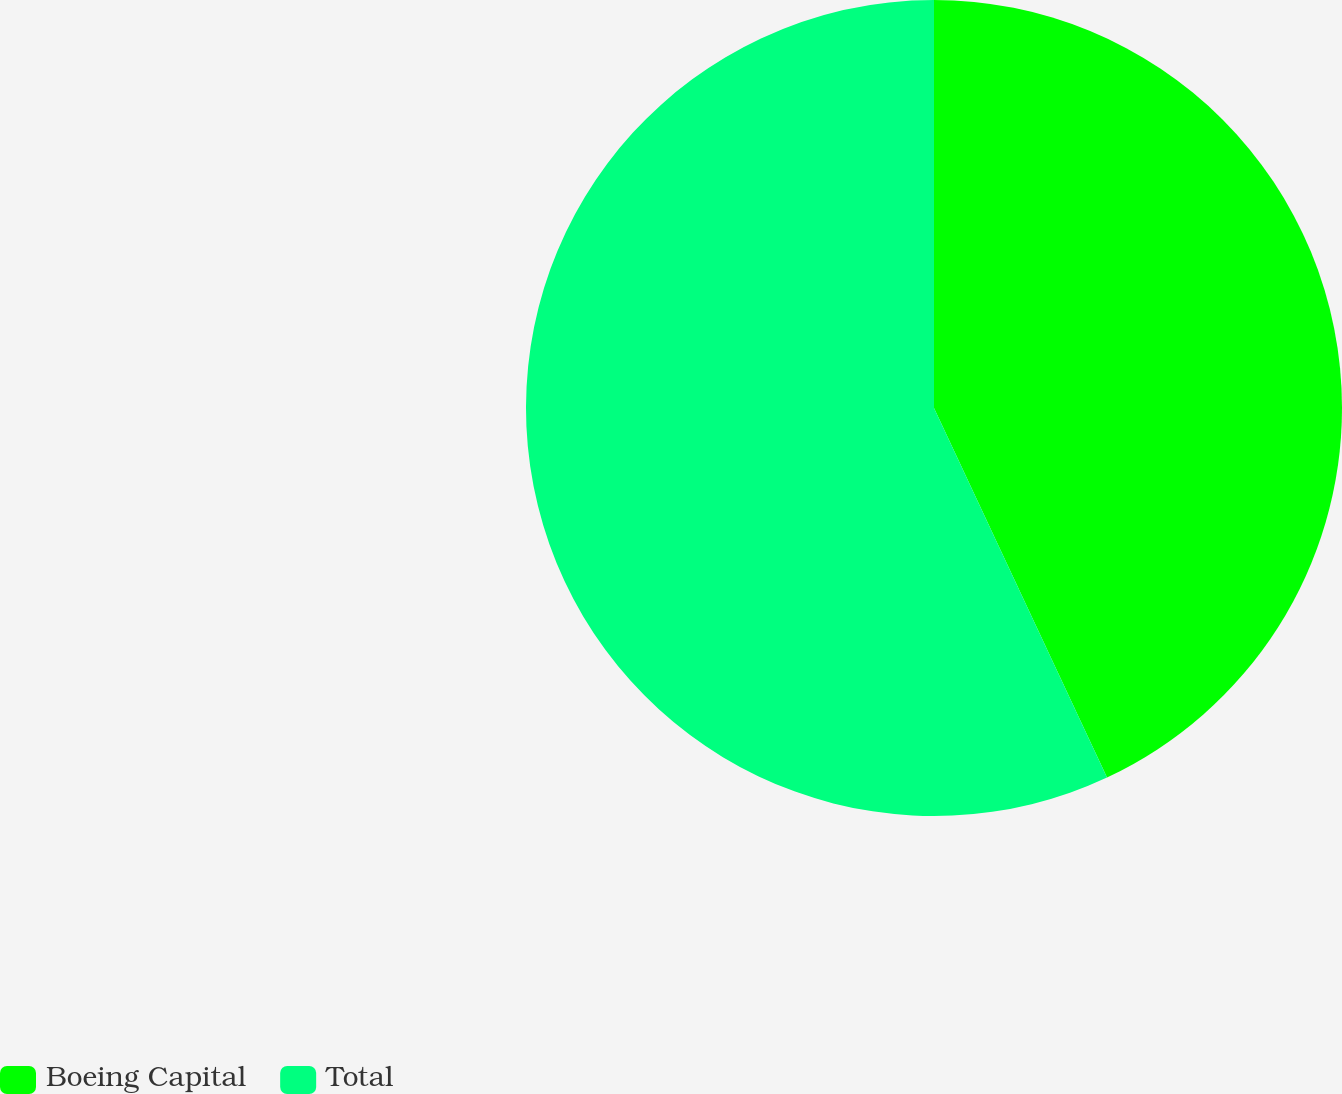<chart> <loc_0><loc_0><loc_500><loc_500><pie_chart><fcel>Boeing Capital<fcel>Total<nl><fcel>43.03%<fcel>56.97%<nl></chart> 